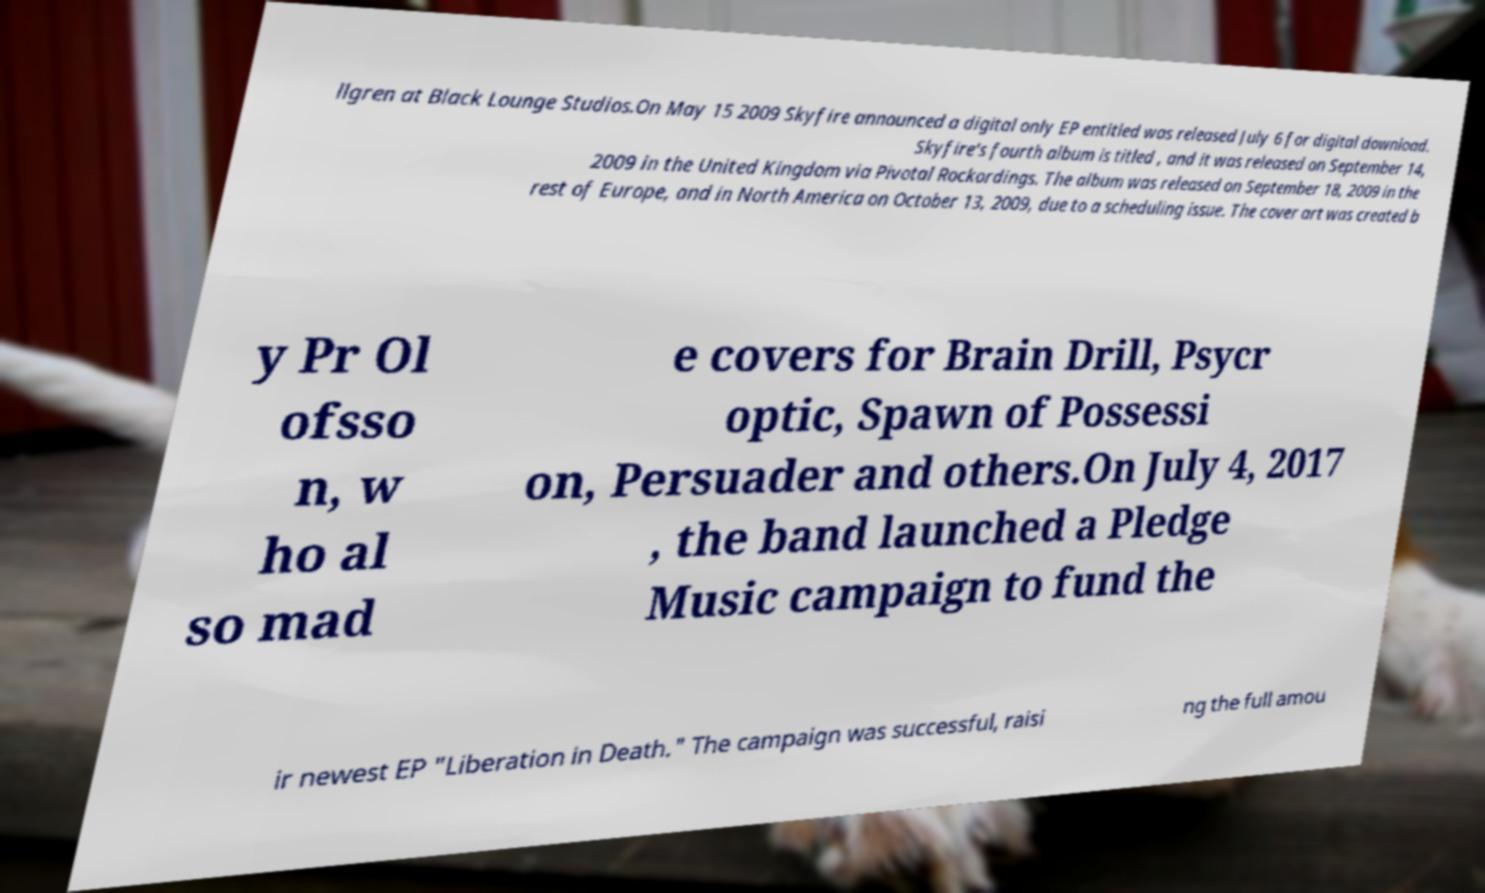Can you read and provide the text displayed in the image?This photo seems to have some interesting text. Can you extract and type it out for me? llgren at Black Lounge Studios.On May 15 2009 Skyfire announced a digital only EP entitled was released July 6 for digital download. Skyfire's fourth album is titled , and it was released on September 14, 2009 in the United Kingdom via Pivotal Rockordings. The album was released on September 18, 2009 in the rest of Europe, and in North America on October 13, 2009, due to a scheduling issue. The cover art was created b y Pr Ol ofsso n, w ho al so mad e covers for Brain Drill, Psycr optic, Spawn of Possessi on, Persuader and others.On July 4, 2017 , the band launched a Pledge Music campaign to fund the ir newest EP "Liberation in Death." The campaign was successful, raisi ng the full amou 